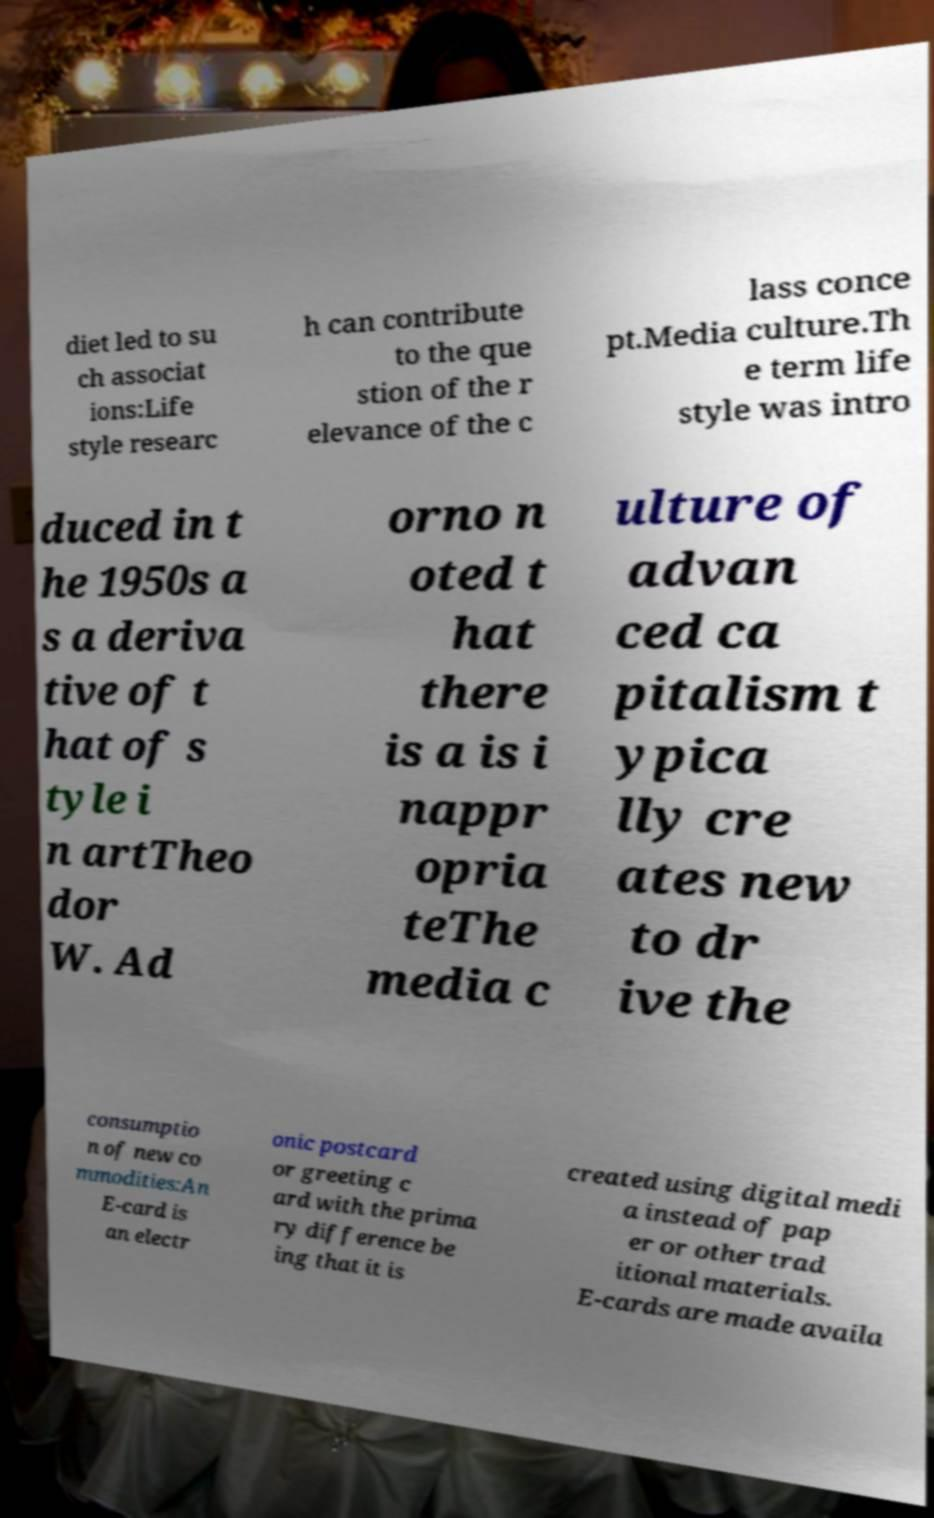Please read and relay the text visible in this image. What does it say? diet led to su ch associat ions:Life style researc h can contribute to the que stion of the r elevance of the c lass conce pt.Media culture.Th e term life style was intro duced in t he 1950s a s a deriva tive of t hat of s tyle i n artTheo dor W. Ad orno n oted t hat there is a is i nappr opria teThe media c ulture of advan ced ca pitalism t ypica lly cre ates new to dr ive the consumptio n of new co mmodities:An E-card is an electr onic postcard or greeting c ard with the prima ry difference be ing that it is created using digital medi a instead of pap er or other trad itional materials. E-cards are made availa 